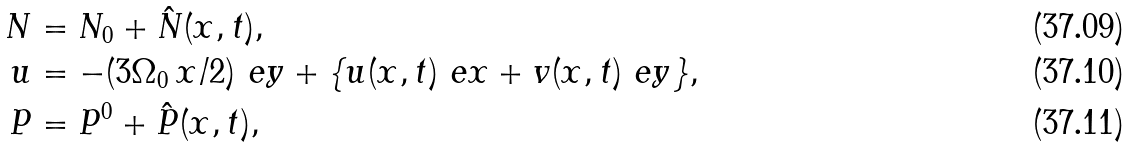<formula> <loc_0><loc_0><loc_500><loc_500>N & = N _ { 0 } + \hat { N } ( x , t ) , \\ \ u & = - ( 3 \Omega _ { 0 } \, x / 2 ) \ e y + \{ u ( x , t ) \ e x + v ( x , t ) \ e y \} , \\ P & = P ^ { 0 } + \hat { P } ( x , t ) ,</formula> 